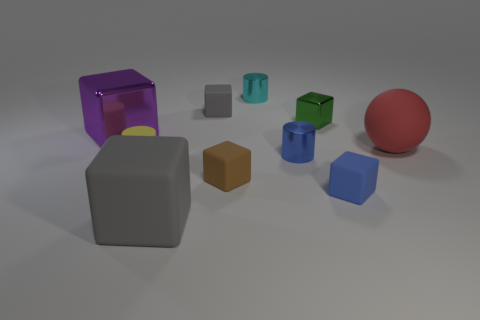Subtract 2 blocks. How many blocks are left? 4 Subtract all brown cubes. How many cubes are left? 5 Subtract all big matte blocks. How many blocks are left? 5 Subtract all red cubes. Subtract all purple balls. How many cubes are left? 6 Subtract all balls. How many objects are left? 9 Add 4 big red rubber spheres. How many big red rubber spheres are left? 5 Add 4 big yellow balls. How many big yellow balls exist? 4 Subtract 0 blue balls. How many objects are left? 10 Subtract all big yellow shiny things. Subtract all brown cubes. How many objects are left? 9 